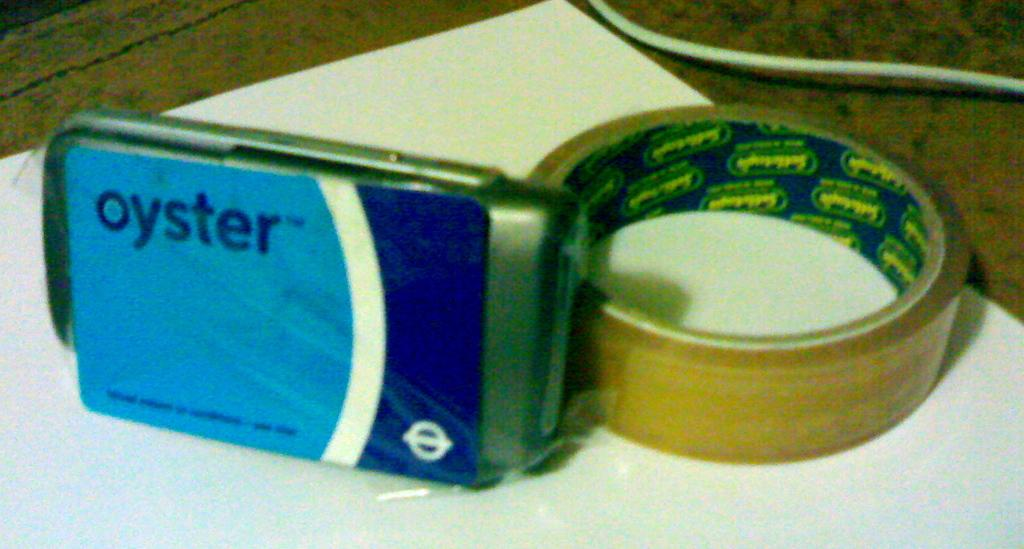What is the main object in the image? There is a tape in the image. What is the tape placed on? The tape is placed on a white sheet. What else can be seen beside the tape? There is another object placed beside the tape. Where is the cable located in the image? There is a cable in the right corner of the image. What type of attraction can be seen in the image? There is no attraction present in the image; it only features a tape, a white sheet, another object, and a cable. Can you tell me how many yaks are visible in the image? There are no yaks present in the image. 